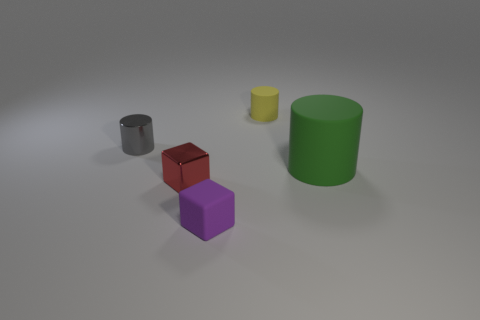What material is the tiny block to the left of the tiny matte object in front of the shiny object that is behind the large rubber object?
Keep it short and to the point. Metal. What material is the tiny red block?
Your answer should be very brief. Metal. Do the red object and the tiny cylinder right of the matte cube have the same material?
Offer a very short reply. No. There is a tiny object that is to the right of the small matte object left of the tiny yellow object; what color is it?
Your response must be concise. Yellow. There is a thing that is both right of the small red thing and on the left side of the tiny yellow rubber object; what size is it?
Make the answer very short. Small. What number of other objects are the same shape as the tiny gray metal thing?
Keep it short and to the point. 2. There is a tiny purple object; is its shape the same as the shiny object to the right of the gray cylinder?
Provide a succinct answer. Yes. How many large green cylinders are to the right of the yellow rubber cylinder?
Make the answer very short. 1. There is a small metal object that is in front of the big cylinder; is it the same shape as the large green matte object?
Offer a very short reply. No. There is a shiny thing behind the green matte thing; what color is it?
Your answer should be compact. Gray. 